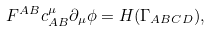Convert formula to latex. <formula><loc_0><loc_0><loc_500><loc_500>F ^ { A B } c ^ { \mu } _ { A B } \partial _ { \mu } \phi = H ( \Gamma _ { A B C D } ) ,</formula> 